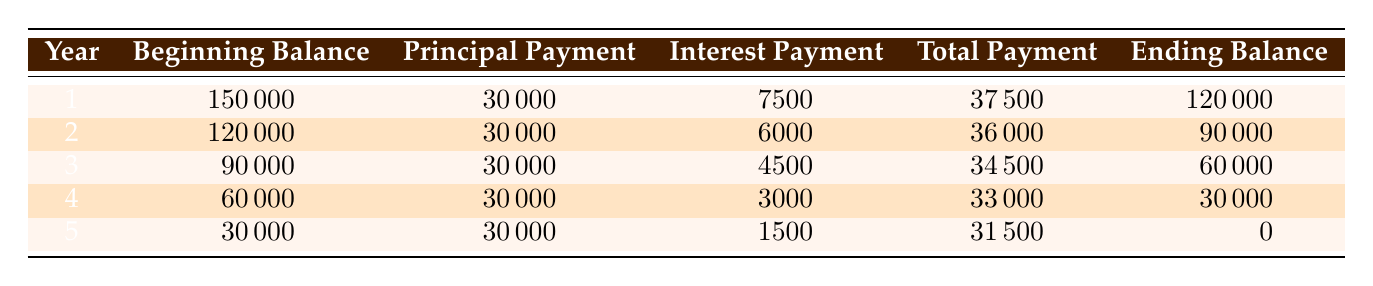What is the total investment amount? The table indicates the "total_investment" in the data, which is $150,000.
Answer: 150000 How much is the principal payment in year 3? In year 3, the "principal_payment" is specified in the table as $30,000.
Answer: 30000 What is the total payment in year 4? In year 4, the "total_payment" listed in the table is $33,000.
Answer: 33000 What is the total interest paid across all five years? To find this, sum the interest payments over the years: 7500 + 6000 + 4500 + 3000 + 1500 = 22500.
Answer: 22500 Is the ending balance zero in the last year? In year 5, the "ending_balance" is listed as zero, confirming that the loan is fully amortized by the end of the term.
Answer: Yes What is the change in the principal payment from year 1 to year 5? The principal payment has remained constant at $30,000 throughout all years, so the change is 0.
Answer: 0 How much interest was paid in year 2 compared to year 3? The interest payment in year 2 is $6,000, and in year 3 it is $4,500. The change between these two years is $6,000 - $4,500 = $1,500, indicating a decrease of interest paid.
Answer: Decrease of 1500 What is the average total payment per year over the loan term? To find the average total payment, sum all the total payments: 37500 + 36000 + 34500 + 33000 + 31500 = 172500. Then divide by 5 years: 172500 / 5 = 34500.
Answer: 34500 In which year does the principal payment remain constant? The table shows that the principal payment is constant at $30,000 for all five years, so the answer applies to all years.
Answer: All years 